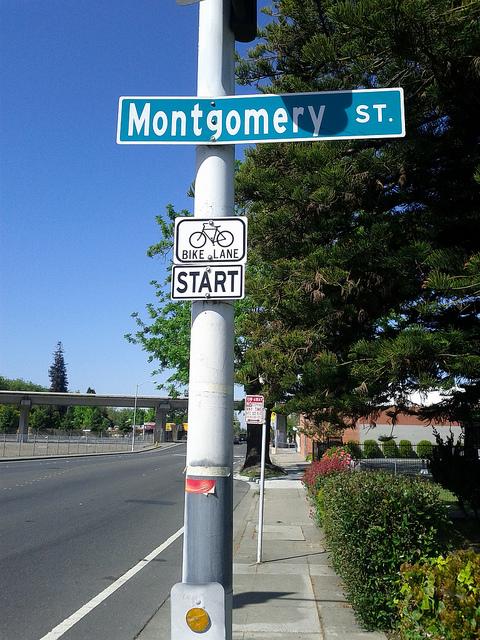Is there a bike lane here?
Keep it brief. Yes. What does the street name say?
Answer briefly. Montgomery. Can you see a street?
Short answer required. Yes. 